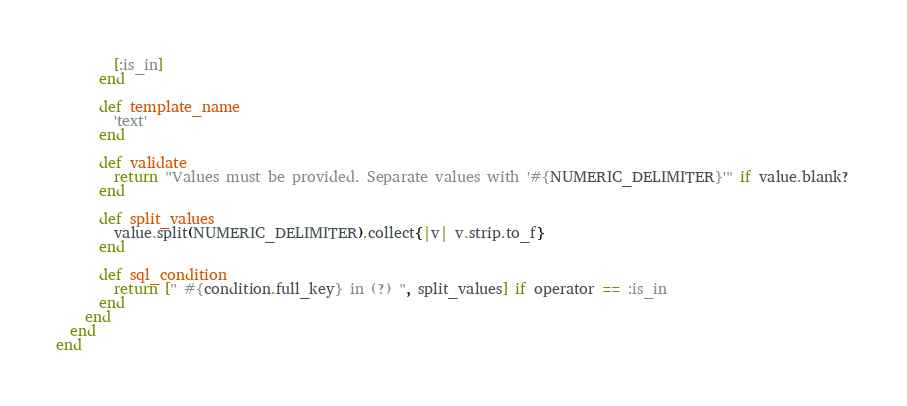<code> <loc_0><loc_0><loc_500><loc_500><_Ruby_>        [:is_in]
      end
    
      def template_name
        'text'
      end
    
      def validate
        return "Values must be provided. Separate values with '#{NUMERIC_DELIMITER}'" if value.blank?
      end
    
      def split_values
        value.split(NUMERIC_DELIMITER).collect{|v| v.strip.to_f}
      end
    
      def sql_condition
        return [" #{condition.full_key} in (?) ", split_values] if operator == :is_in
      end
    end
  end
end</code> 